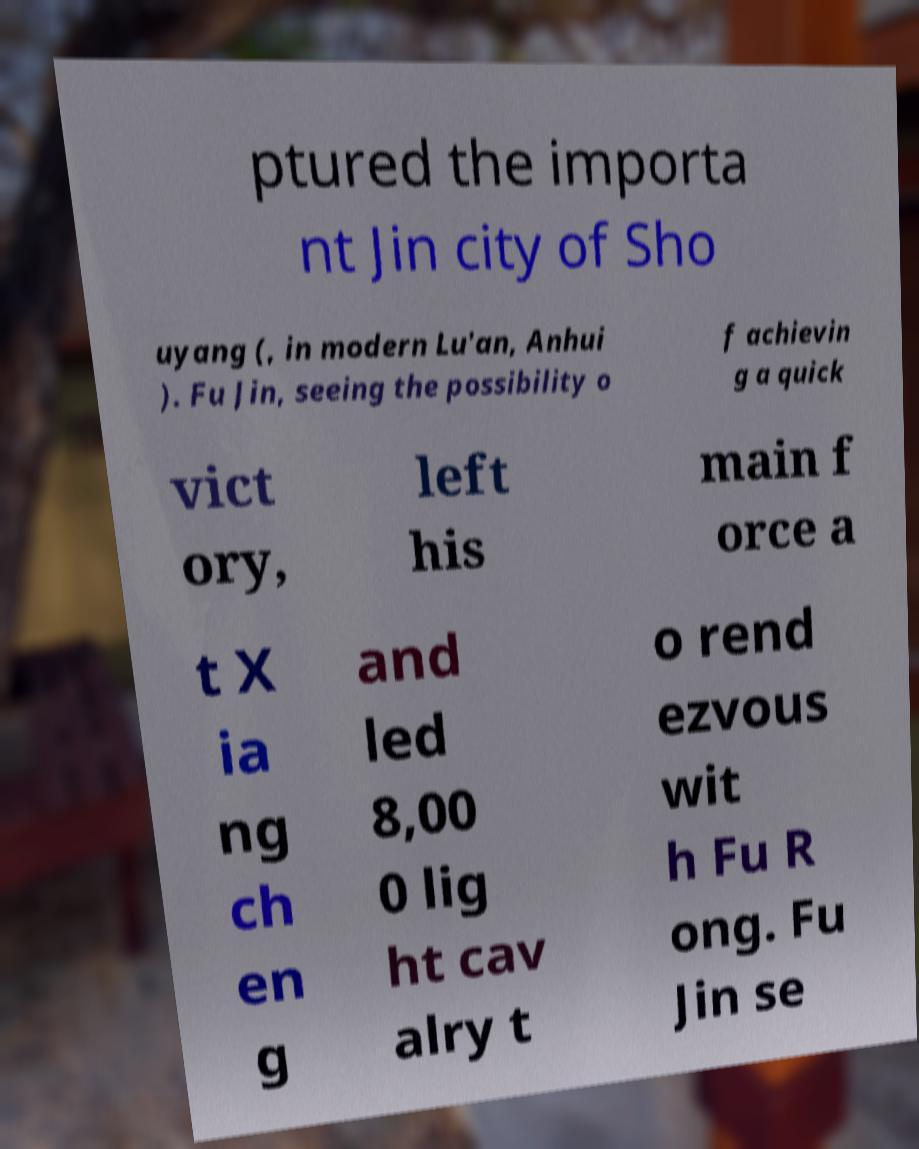There's text embedded in this image that I need extracted. Can you transcribe it verbatim? ptured the importa nt Jin city of Sho uyang (, in modern Lu'an, Anhui ). Fu Jin, seeing the possibility o f achievin g a quick vict ory, left his main f orce a t X ia ng ch en g and led 8,00 0 lig ht cav alry t o rend ezvous wit h Fu R ong. Fu Jin se 